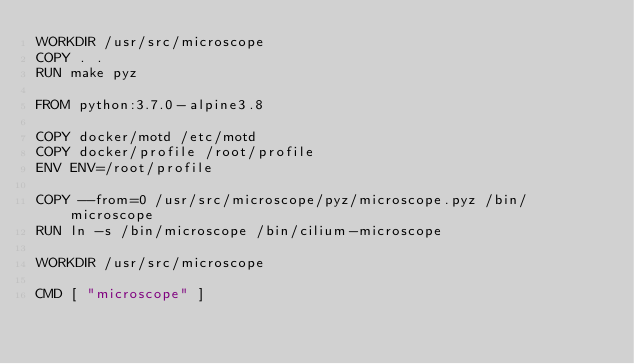Convert code to text. <code><loc_0><loc_0><loc_500><loc_500><_Dockerfile_>WORKDIR /usr/src/microscope
COPY . .
RUN make pyz

FROM python:3.7.0-alpine3.8

COPY docker/motd /etc/motd
COPY docker/profile /root/profile
ENV ENV=/root/profile

COPY --from=0 /usr/src/microscope/pyz/microscope.pyz /bin/microscope
RUN ln -s /bin/microscope /bin/cilium-microscope

WORKDIR /usr/src/microscope

CMD [ "microscope" ]
</code> 